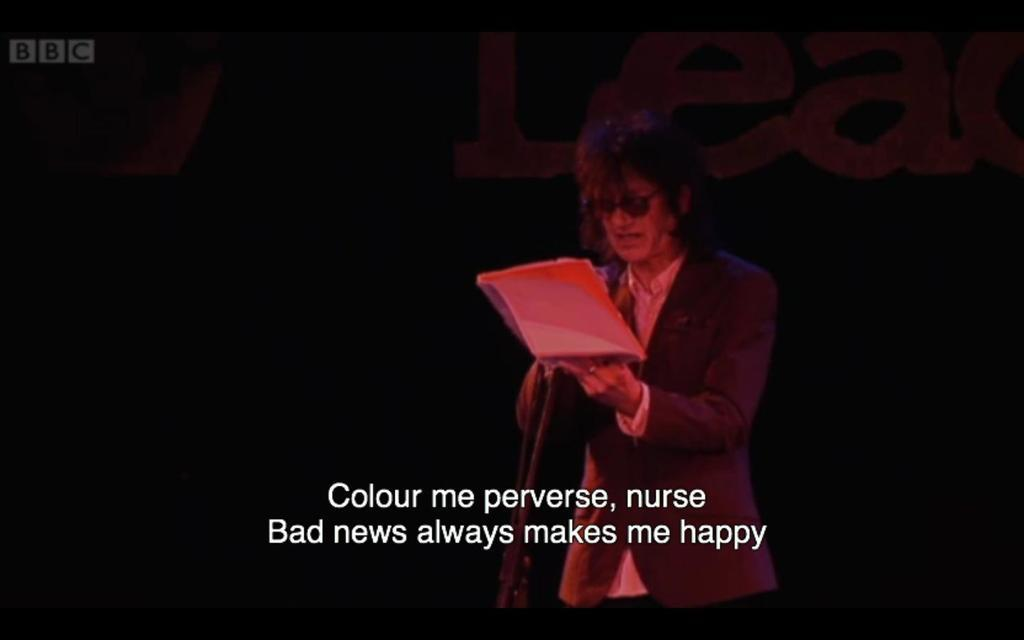What can be seen in the image? There is a person in the image. Can you describe the person's attire? The person is wearing a dress. What is the person holding in the image? The person is holding an object. Is there any text present in the image? Yes, there is text written on the image. What is the color of the background in the image? The background of the image is black. What type of celery is being used as a volleyball in the image? There is no celery or volleyball present in the image. What color is the cream on the person's dress in the image? There is no cream mentioned on the person's dress in the image. 